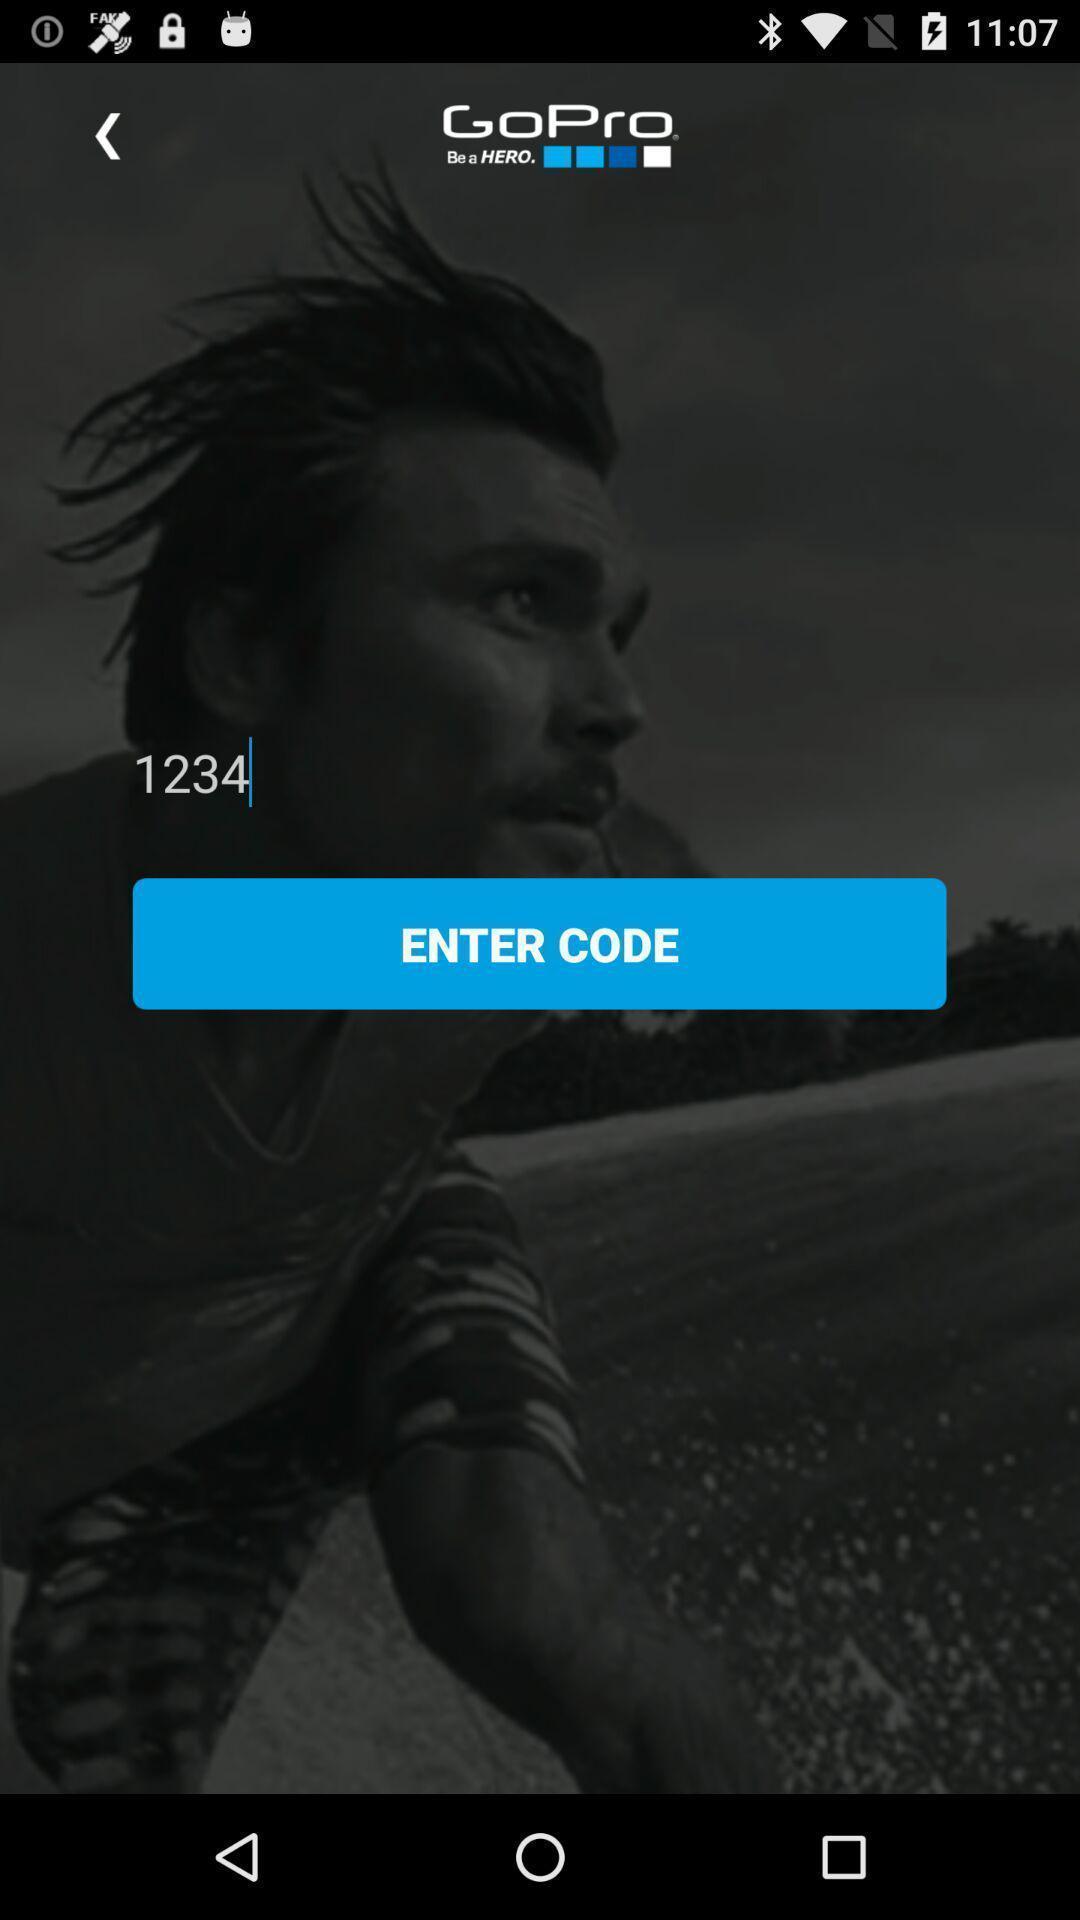Give me a summary of this screen capture. Screen shows to enter code for an application. 